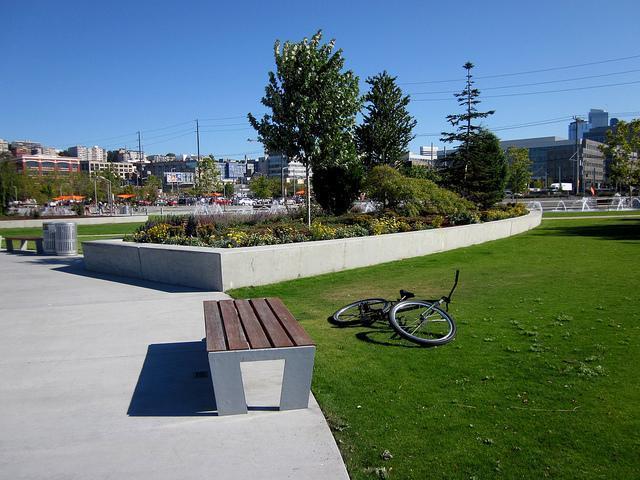How many benches are there?
Give a very brief answer. 2. How many benches are in the picture?
Give a very brief answer. 2. 